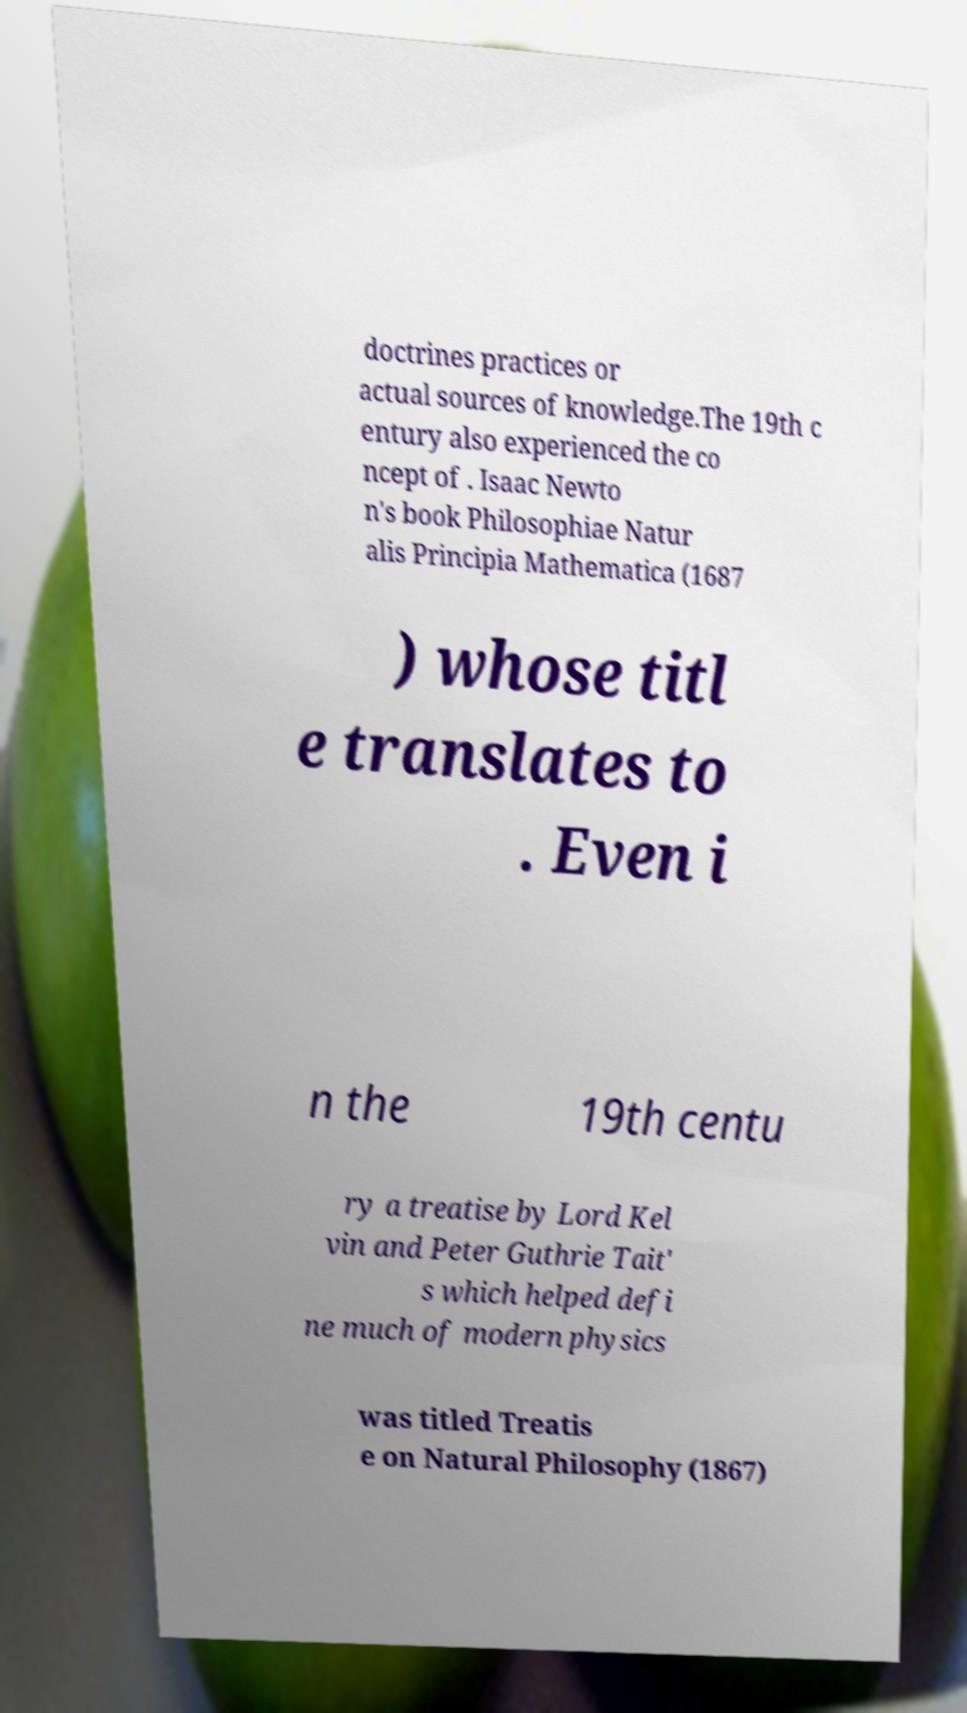Please identify and transcribe the text found in this image. doctrines practices or actual sources of knowledge.The 19th c entury also experienced the co ncept of . Isaac Newto n's book Philosophiae Natur alis Principia Mathematica (1687 ) whose titl e translates to . Even i n the 19th centu ry a treatise by Lord Kel vin and Peter Guthrie Tait' s which helped defi ne much of modern physics was titled Treatis e on Natural Philosophy (1867) 